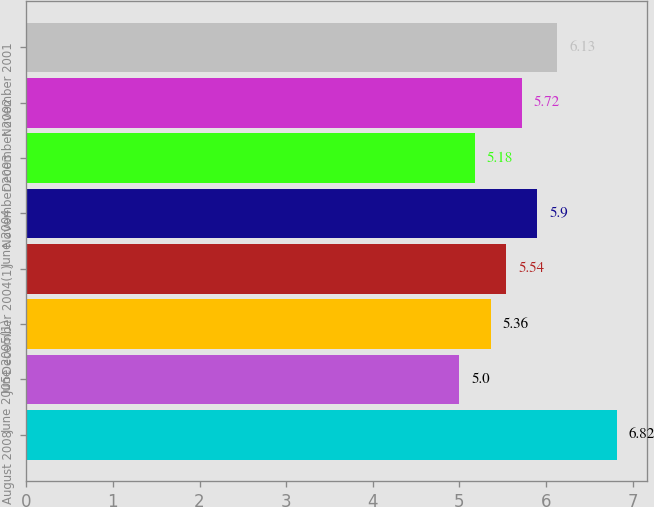Convert chart to OTSL. <chart><loc_0><loc_0><loc_500><loc_500><bar_chart><fcel>August 2008<fcel>June 2005<fcel>June 2005(1)<fcel>December 2004(1)<fcel>June 2004<fcel>November 2003<fcel>December 2002<fcel>November 2001<nl><fcel>6.82<fcel>5<fcel>5.36<fcel>5.54<fcel>5.9<fcel>5.18<fcel>5.72<fcel>6.13<nl></chart> 